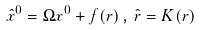Convert formula to latex. <formula><loc_0><loc_0><loc_500><loc_500>\hat { x } ^ { 0 } = \Omega x ^ { 0 } + f ( r ) \, , \, \hat { r } = K ( r )</formula> 